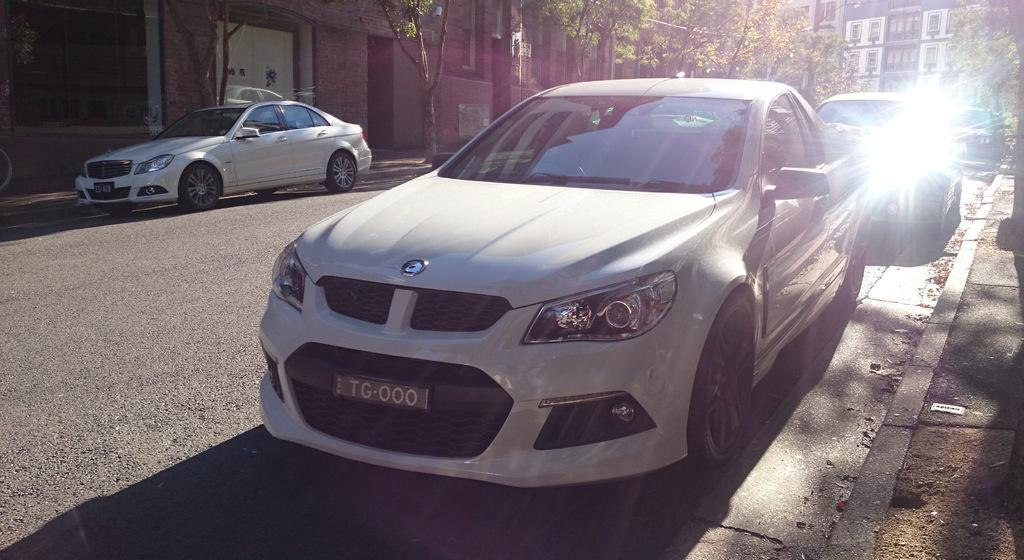What can be seen on the road in the image? There are cars on the road in the image. What is visible in the background of the image? There are trees and buildings in the background of the image. What plot of land is being offered for sale in the image? There is no plot of land being offered for sale in the image. What type of work is being done by the trees in the image? The trees are not performing any work in the image; they are simply standing in the background. 